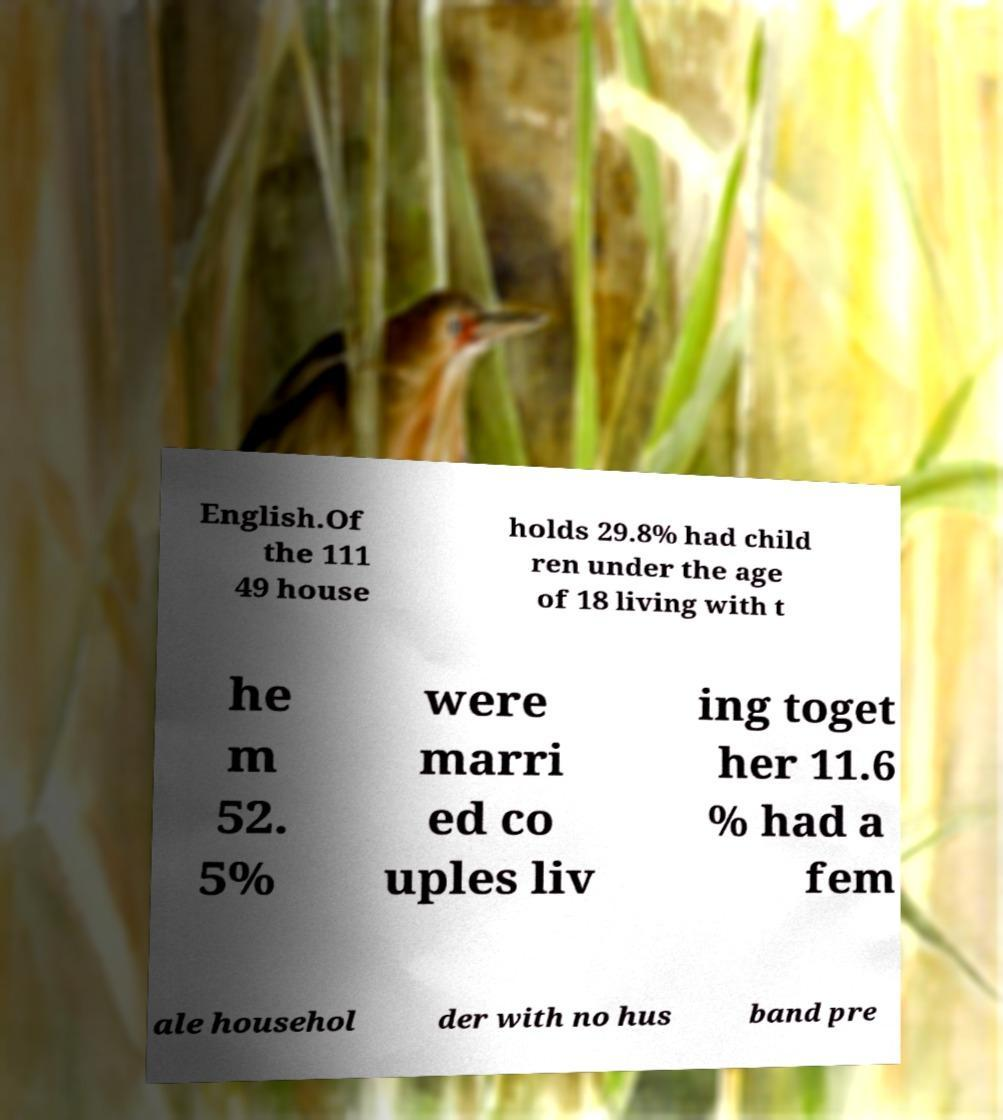What messages or text are displayed in this image? I need them in a readable, typed format. English.Of the 111 49 house holds 29.8% had child ren under the age of 18 living with t he m 52. 5% were marri ed co uples liv ing toget her 11.6 % had a fem ale househol der with no hus band pre 